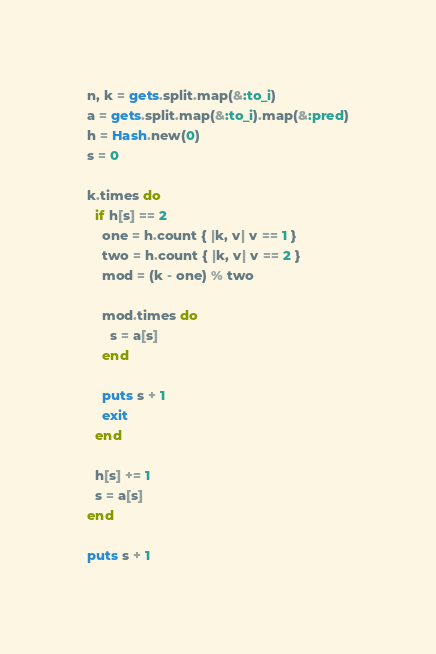Convert code to text. <code><loc_0><loc_0><loc_500><loc_500><_Ruby_>n, k = gets.split.map(&:to_i)
a = gets.split.map(&:to_i).map(&:pred)
h = Hash.new(0)
s = 0

k.times do
  if h[s] == 2
    one = h.count { |k, v| v == 1 }
    two = h.count { |k, v| v == 2 }
    mod = (k - one) % two

    mod.times do
      s = a[s]
    end

    puts s + 1
    exit
  end

  h[s] += 1
  s = a[s]
end

puts s + 1</code> 